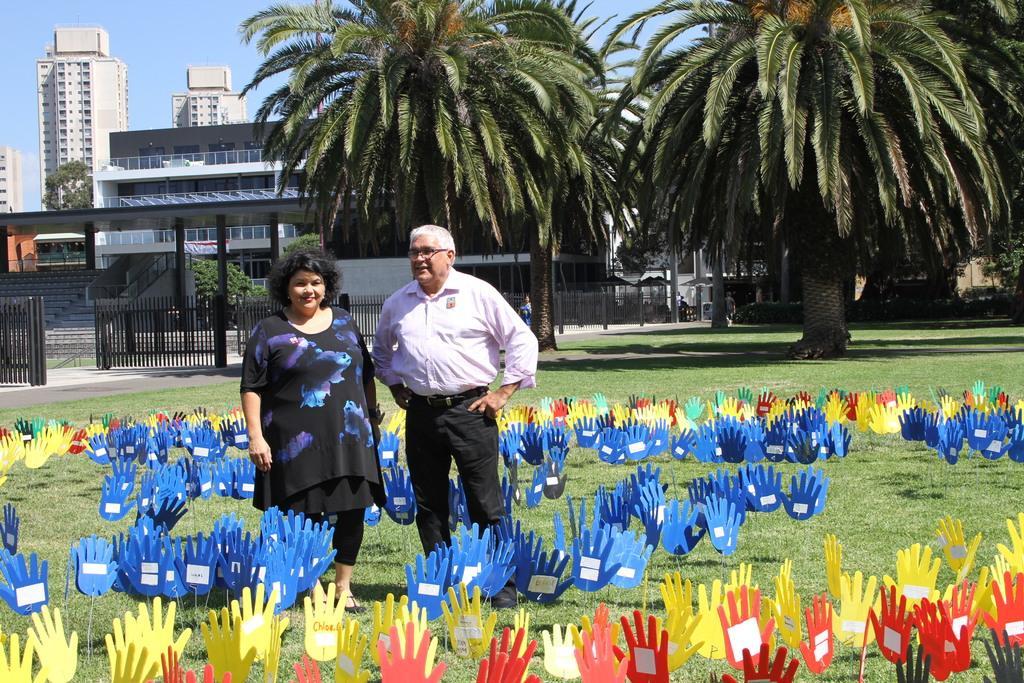Could you give a brief overview of what you see in this image? In the picture we can see a man and a woman standing on the grass surface, on it we can see some colored hand shape papers are placed on it and in the background we can see railing, poles, trees, tower buildings and sky. 